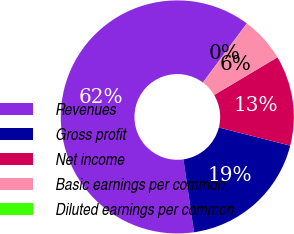Convert chart to OTSL. <chart><loc_0><loc_0><loc_500><loc_500><pie_chart><fcel>Revenues<fcel>Gross profit<fcel>Net income<fcel>Basic earnings per common<fcel>Diluted earnings per common<nl><fcel>62.47%<fcel>18.75%<fcel>12.51%<fcel>6.26%<fcel>0.02%<nl></chart> 